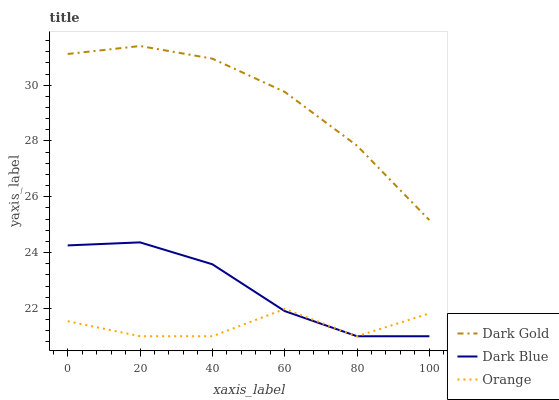Does Dark Blue have the minimum area under the curve?
Answer yes or no. No. Does Dark Blue have the maximum area under the curve?
Answer yes or no. No. Is Dark Blue the smoothest?
Answer yes or no. No. Is Dark Blue the roughest?
Answer yes or no. No. Does Dark Gold have the lowest value?
Answer yes or no. No. Does Dark Blue have the highest value?
Answer yes or no. No. Is Dark Blue less than Dark Gold?
Answer yes or no. Yes. Is Dark Gold greater than Orange?
Answer yes or no. Yes. Does Dark Blue intersect Dark Gold?
Answer yes or no. No. 